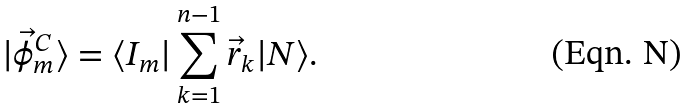<formula> <loc_0><loc_0><loc_500><loc_500>| \vec { \phi } ^ { C } _ { m } \rangle = \langle I _ { m } | \sum _ { k = 1 } ^ { n - 1 } \vec { r } _ { k } | N \rangle .</formula> 